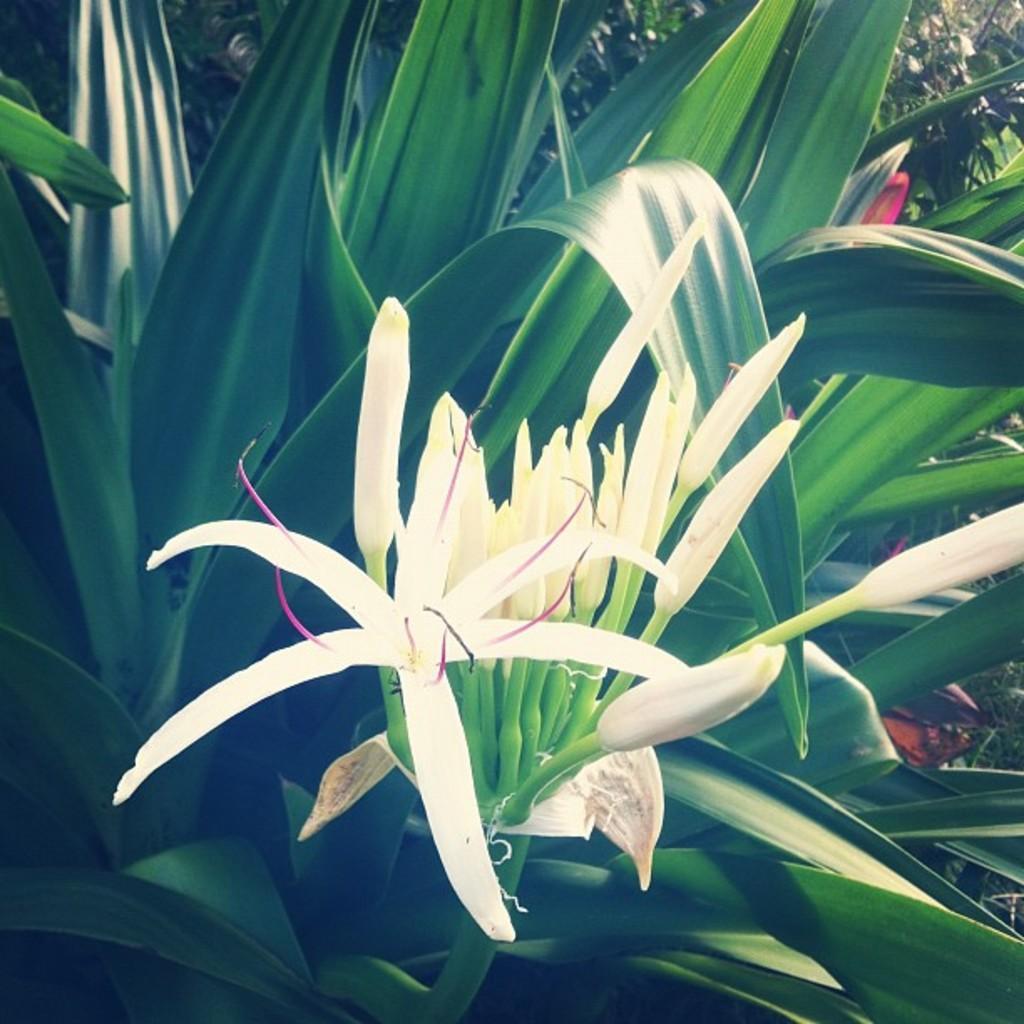Please provide a concise description of this image. In this image there are white flowers and leaves. 